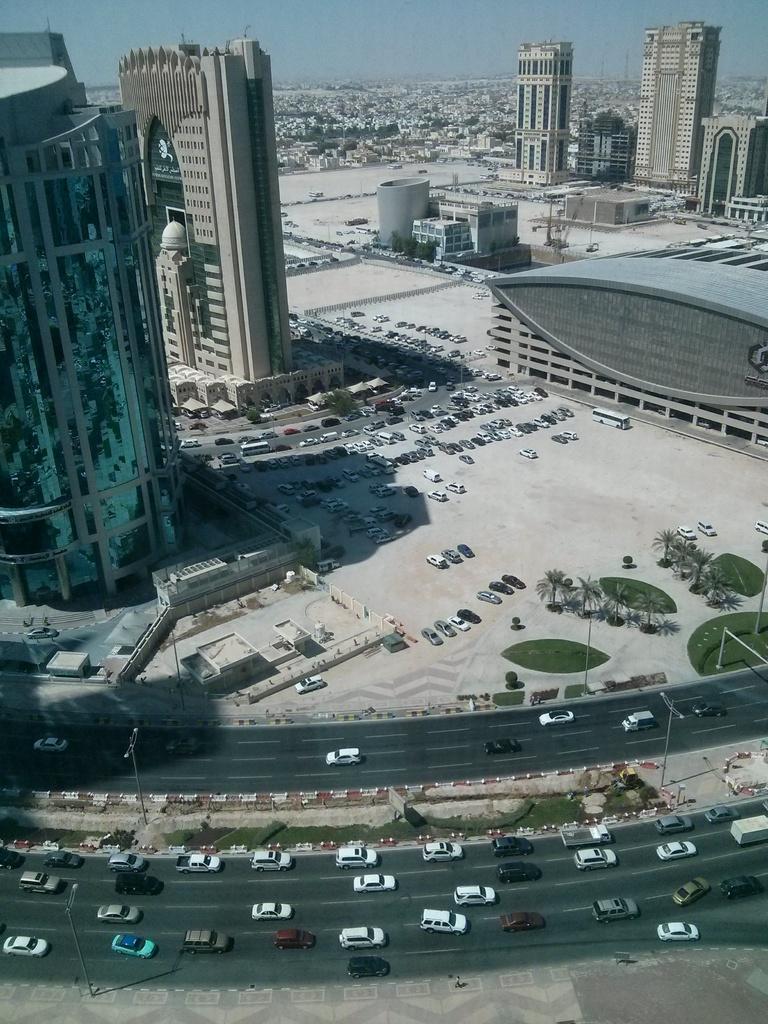Describe this image in one or two sentences. In this image there are some buildings on the left side of this image and right side of this image as well. There are some cars as we can see in middle of this image and in the bottom of this image as well. There are some trees on the right side of this image and there is a sky on the top of this image. 